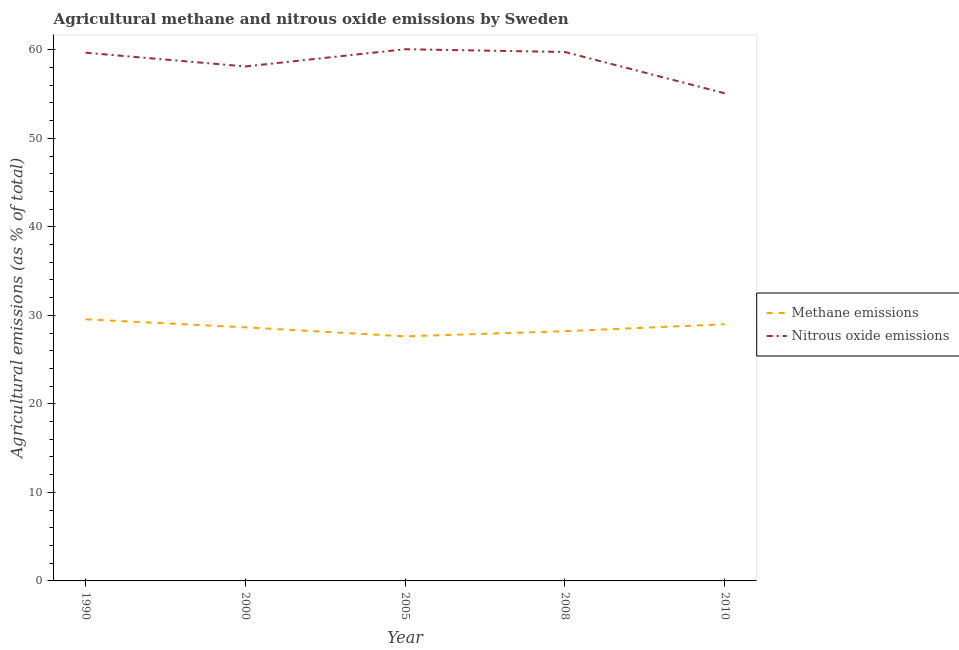How many different coloured lines are there?
Your answer should be very brief. 2. What is the amount of nitrous oxide emissions in 2008?
Provide a short and direct response. 59.75. Across all years, what is the maximum amount of methane emissions?
Provide a succinct answer. 29.55. Across all years, what is the minimum amount of methane emissions?
Give a very brief answer. 27.63. In which year was the amount of nitrous oxide emissions maximum?
Make the answer very short. 2005. In which year was the amount of nitrous oxide emissions minimum?
Provide a short and direct response. 2010. What is the total amount of nitrous oxide emissions in the graph?
Offer a terse response. 292.69. What is the difference between the amount of nitrous oxide emissions in 2000 and that in 2005?
Provide a short and direct response. -1.94. What is the difference between the amount of nitrous oxide emissions in 2005 and the amount of methane emissions in 2000?
Keep it short and to the point. 31.42. What is the average amount of methane emissions per year?
Provide a short and direct response. 28.61. In the year 1990, what is the difference between the amount of nitrous oxide emissions and amount of methane emissions?
Offer a very short reply. 30.12. What is the ratio of the amount of nitrous oxide emissions in 2005 to that in 2010?
Give a very brief answer. 1.09. What is the difference between the highest and the second highest amount of nitrous oxide emissions?
Your response must be concise. 0.31. What is the difference between the highest and the lowest amount of methane emissions?
Your answer should be compact. 1.93. In how many years, is the amount of methane emissions greater than the average amount of methane emissions taken over all years?
Make the answer very short. 3. Is the sum of the amount of methane emissions in 1990 and 2000 greater than the maximum amount of nitrous oxide emissions across all years?
Your answer should be very brief. No. Does the amount of nitrous oxide emissions monotonically increase over the years?
Provide a succinct answer. No. Is the amount of methane emissions strictly greater than the amount of nitrous oxide emissions over the years?
Your answer should be compact. No. Is the amount of nitrous oxide emissions strictly less than the amount of methane emissions over the years?
Your answer should be very brief. No. How many legend labels are there?
Give a very brief answer. 2. What is the title of the graph?
Offer a very short reply. Agricultural methane and nitrous oxide emissions by Sweden. Does "Commercial service exports" appear as one of the legend labels in the graph?
Make the answer very short. No. What is the label or title of the X-axis?
Provide a short and direct response. Year. What is the label or title of the Y-axis?
Provide a short and direct response. Agricultural emissions (as % of total). What is the Agricultural emissions (as % of total) of Methane emissions in 1990?
Make the answer very short. 29.55. What is the Agricultural emissions (as % of total) in Nitrous oxide emissions in 1990?
Your answer should be compact. 59.67. What is the Agricultural emissions (as % of total) in Methane emissions in 2000?
Offer a very short reply. 28.65. What is the Agricultural emissions (as % of total) in Nitrous oxide emissions in 2000?
Make the answer very short. 58.12. What is the Agricultural emissions (as % of total) of Methane emissions in 2005?
Offer a very short reply. 27.63. What is the Agricultural emissions (as % of total) in Nitrous oxide emissions in 2005?
Give a very brief answer. 60.06. What is the Agricultural emissions (as % of total) of Methane emissions in 2008?
Ensure brevity in your answer.  28.21. What is the Agricultural emissions (as % of total) in Nitrous oxide emissions in 2008?
Give a very brief answer. 59.75. What is the Agricultural emissions (as % of total) in Methane emissions in 2010?
Offer a terse response. 29. What is the Agricultural emissions (as % of total) of Nitrous oxide emissions in 2010?
Provide a succinct answer. 55.09. Across all years, what is the maximum Agricultural emissions (as % of total) in Methane emissions?
Your answer should be very brief. 29.55. Across all years, what is the maximum Agricultural emissions (as % of total) of Nitrous oxide emissions?
Your answer should be compact. 60.06. Across all years, what is the minimum Agricultural emissions (as % of total) in Methane emissions?
Provide a succinct answer. 27.63. Across all years, what is the minimum Agricultural emissions (as % of total) in Nitrous oxide emissions?
Provide a succinct answer. 55.09. What is the total Agricultural emissions (as % of total) in Methane emissions in the graph?
Provide a succinct answer. 143.04. What is the total Agricultural emissions (as % of total) of Nitrous oxide emissions in the graph?
Provide a short and direct response. 292.69. What is the difference between the Agricultural emissions (as % of total) in Methane emissions in 1990 and that in 2000?
Keep it short and to the point. 0.91. What is the difference between the Agricultural emissions (as % of total) of Nitrous oxide emissions in 1990 and that in 2000?
Your answer should be compact. 1.55. What is the difference between the Agricultural emissions (as % of total) of Methane emissions in 1990 and that in 2005?
Provide a short and direct response. 1.93. What is the difference between the Agricultural emissions (as % of total) in Nitrous oxide emissions in 1990 and that in 2005?
Your answer should be very brief. -0.39. What is the difference between the Agricultural emissions (as % of total) in Methane emissions in 1990 and that in 2008?
Your answer should be very brief. 1.34. What is the difference between the Agricultural emissions (as % of total) of Nitrous oxide emissions in 1990 and that in 2008?
Provide a succinct answer. -0.08. What is the difference between the Agricultural emissions (as % of total) of Methane emissions in 1990 and that in 2010?
Your response must be concise. 0.56. What is the difference between the Agricultural emissions (as % of total) in Nitrous oxide emissions in 1990 and that in 2010?
Your response must be concise. 4.59. What is the difference between the Agricultural emissions (as % of total) of Methane emissions in 2000 and that in 2005?
Offer a very short reply. 1.02. What is the difference between the Agricultural emissions (as % of total) in Nitrous oxide emissions in 2000 and that in 2005?
Provide a succinct answer. -1.94. What is the difference between the Agricultural emissions (as % of total) in Methane emissions in 2000 and that in 2008?
Your answer should be compact. 0.44. What is the difference between the Agricultural emissions (as % of total) in Nitrous oxide emissions in 2000 and that in 2008?
Your answer should be compact. -1.63. What is the difference between the Agricultural emissions (as % of total) in Methane emissions in 2000 and that in 2010?
Offer a very short reply. -0.35. What is the difference between the Agricultural emissions (as % of total) of Nitrous oxide emissions in 2000 and that in 2010?
Ensure brevity in your answer.  3.03. What is the difference between the Agricultural emissions (as % of total) of Methane emissions in 2005 and that in 2008?
Your answer should be very brief. -0.58. What is the difference between the Agricultural emissions (as % of total) in Nitrous oxide emissions in 2005 and that in 2008?
Offer a very short reply. 0.31. What is the difference between the Agricultural emissions (as % of total) in Methane emissions in 2005 and that in 2010?
Make the answer very short. -1.37. What is the difference between the Agricultural emissions (as % of total) in Nitrous oxide emissions in 2005 and that in 2010?
Offer a terse response. 4.98. What is the difference between the Agricultural emissions (as % of total) in Methane emissions in 2008 and that in 2010?
Ensure brevity in your answer.  -0.79. What is the difference between the Agricultural emissions (as % of total) in Nitrous oxide emissions in 2008 and that in 2010?
Provide a succinct answer. 4.67. What is the difference between the Agricultural emissions (as % of total) of Methane emissions in 1990 and the Agricultural emissions (as % of total) of Nitrous oxide emissions in 2000?
Ensure brevity in your answer.  -28.56. What is the difference between the Agricultural emissions (as % of total) in Methane emissions in 1990 and the Agricultural emissions (as % of total) in Nitrous oxide emissions in 2005?
Keep it short and to the point. -30.51. What is the difference between the Agricultural emissions (as % of total) in Methane emissions in 1990 and the Agricultural emissions (as % of total) in Nitrous oxide emissions in 2008?
Your answer should be very brief. -30.2. What is the difference between the Agricultural emissions (as % of total) in Methane emissions in 1990 and the Agricultural emissions (as % of total) in Nitrous oxide emissions in 2010?
Offer a very short reply. -25.53. What is the difference between the Agricultural emissions (as % of total) of Methane emissions in 2000 and the Agricultural emissions (as % of total) of Nitrous oxide emissions in 2005?
Your answer should be compact. -31.42. What is the difference between the Agricultural emissions (as % of total) in Methane emissions in 2000 and the Agricultural emissions (as % of total) in Nitrous oxide emissions in 2008?
Ensure brevity in your answer.  -31.1. What is the difference between the Agricultural emissions (as % of total) of Methane emissions in 2000 and the Agricultural emissions (as % of total) of Nitrous oxide emissions in 2010?
Provide a succinct answer. -26.44. What is the difference between the Agricultural emissions (as % of total) in Methane emissions in 2005 and the Agricultural emissions (as % of total) in Nitrous oxide emissions in 2008?
Provide a short and direct response. -32.12. What is the difference between the Agricultural emissions (as % of total) of Methane emissions in 2005 and the Agricultural emissions (as % of total) of Nitrous oxide emissions in 2010?
Provide a succinct answer. -27.46. What is the difference between the Agricultural emissions (as % of total) in Methane emissions in 2008 and the Agricultural emissions (as % of total) in Nitrous oxide emissions in 2010?
Your response must be concise. -26.87. What is the average Agricultural emissions (as % of total) of Methane emissions per year?
Your response must be concise. 28.61. What is the average Agricultural emissions (as % of total) in Nitrous oxide emissions per year?
Your response must be concise. 58.54. In the year 1990, what is the difference between the Agricultural emissions (as % of total) in Methane emissions and Agricultural emissions (as % of total) in Nitrous oxide emissions?
Provide a short and direct response. -30.12. In the year 2000, what is the difference between the Agricultural emissions (as % of total) in Methane emissions and Agricultural emissions (as % of total) in Nitrous oxide emissions?
Provide a succinct answer. -29.47. In the year 2005, what is the difference between the Agricultural emissions (as % of total) in Methane emissions and Agricultural emissions (as % of total) in Nitrous oxide emissions?
Provide a succinct answer. -32.44. In the year 2008, what is the difference between the Agricultural emissions (as % of total) of Methane emissions and Agricultural emissions (as % of total) of Nitrous oxide emissions?
Provide a succinct answer. -31.54. In the year 2010, what is the difference between the Agricultural emissions (as % of total) in Methane emissions and Agricultural emissions (as % of total) in Nitrous oxide emissions?
Give a very brief answer. -26.09. What is the ratio of the Agricultural emissions (as % of total) of Methane emissions in 1990 to that in 2000?
Ensure brevity in your answer.  1.03. What is the ratio of the Agricultural emissions (as % of total) of Nitrous oxide emissions in 1990 to that in 2000?
Ensure brevity in your answer.  1.03. What is the ratio of the Agricultural emissions (as % of total) in Methane emissions in 1990 to that in 2005?
Provide a succinct answer. 1.07. What is the ratio of the Agricultural emissions (as % of total) of Nitrous oxide emissions in 1990 to that in 2005?
Give a very brief answer. 0.99. What is the ratio of the Agricultural emissions (as % of total) in Methane emissions in 1990 to that in 2008?
Offer a very short reply. 1.05. What is the ratio of the Agricultural emissions (as % of total) of Nitrous oxide emissions in 1990 to that in 2008?
Give a very brief answer. 1. What is the ratio of the Agricultural emissions (as % of total) in Methane emissions in 1990 to that in 2010?
Keep it short and to the point. 1.02. What is the ratio of the Agricultural emissions (as % of total) in Nitrous oxide emissions in 1990 to that in 2010?
Your answer should be compact. 1.08. What is the ratio of the Agricultural emissions (as % of total) in Methane emissions in 2000 to that in 2005?
Your answer should be very brief. 1.04. What is the ratio of the Agricultural emissions (as % of total) in Nitrous oxide emissions in 2000 to that in 2005?
Ensure brevity in your answer.  0.97. What is the ratio of the Agricultural emissions (as % of total) in Methane emissions in 2000 to that in 2008?
Give a very brief answer. 1.02. What is the ratio of the Agricultural emissions (as % of total) of Nitrous oxide emissions in 2000 to that in 2008?
Make the answer very short. 0.97. What is the ratio of the Agricultural emissions (as % of total) in Methane emissions in 2000 to that in 2010?
Give a very brief answer. 0.99. What is the ratio of the Agricultural emissions (as % of total) in Nitrous oxide emissions in 2000 to that in 2010?
Provide a short and direct response. 1.06. What is the ratio of the Agricultural emissions (as % of total) in Methane emissions in 2005 to that in 2008?
Provide a succinct answer. 0.98. What is the ratio of the Agricultural emissions (as % of total) in Methane emissions in 2005 to that in 2010?
Provide a short and direct response. 0.95. What is the ratio of the Agricultural emissions (as % of total) of Nitrous oxide emissions in 2005 to that in 2010?
Keep it short and to the point. 1.09. What is the ratio of the Agricultural emissions (as % of total) of Methane emissions in 2008 to that in 2010?
Provide a short and direct response. 0.97. What is the ratio of the Agricultural emissions (as % of total) in Nitrous oxide emissions in 2008 to that in 2010?
Keep it short and to the point. 1.08. What is the difference between the highest and the second highest Agricultural emissions (as % of total) in Methane emissions?
Your answer should be very brief. 0.56. What is the difference between the highest and the second highest Agricultural emissions (as % of total) of Nitrous oxide emissions?
Your response must be concise. 0.31. What is the difference between the highest and the lowest Agricultural emissions (as % of total) in Methane emissions?
Your answer should be compact. 1.93. What is the difference between the highest and the lowest Agricultural emissions (as % of total) in Nitrous oxide emissions?
Keep it short and to the point. 4.98. 